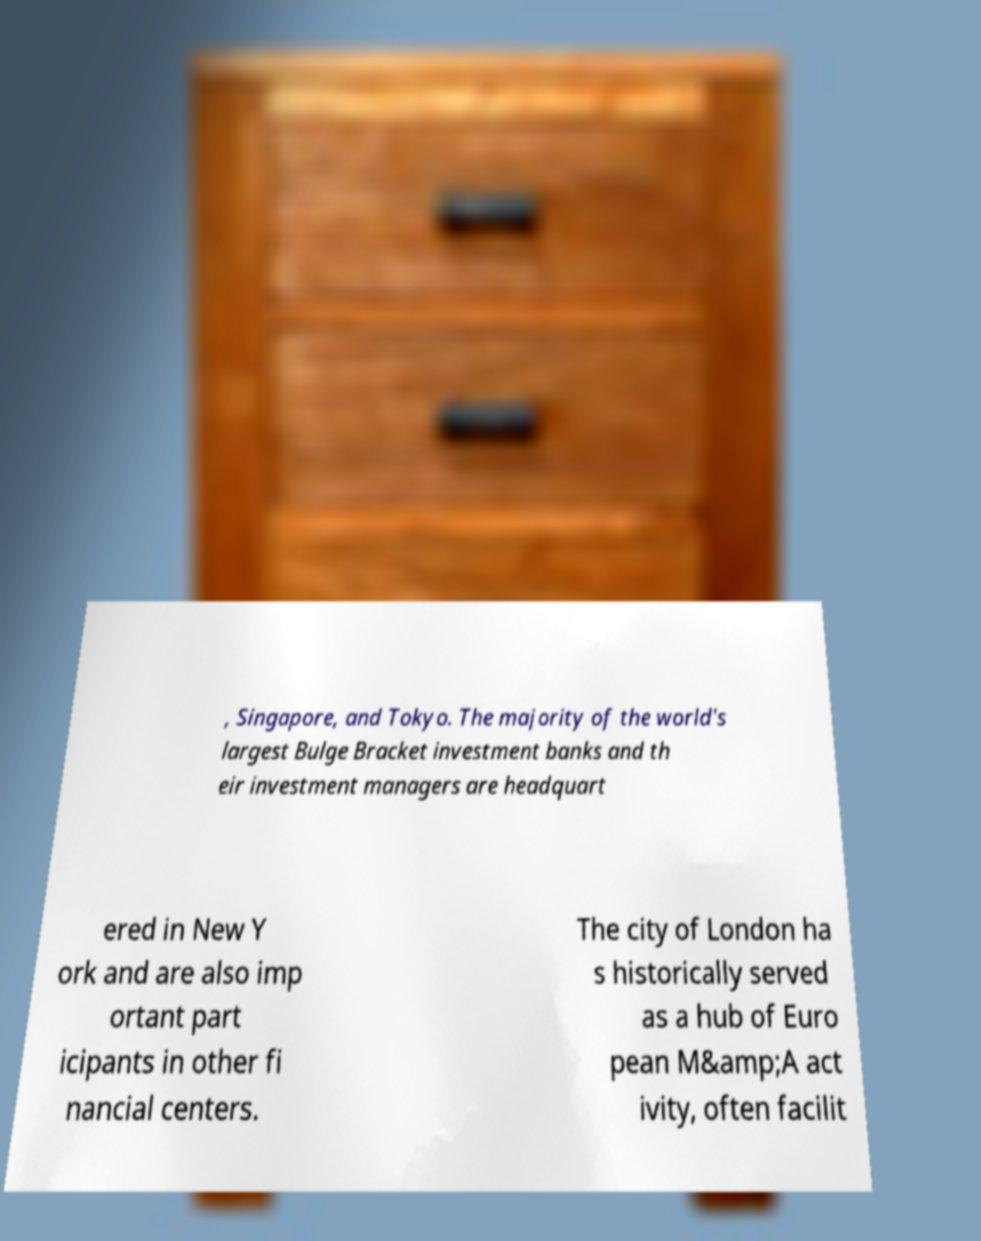Could you extract and type out the text from this image? , Singapore, and Tokyo. The majority of the world's largest Bulge Bracket investment banks and th eir investment managers are headquart ered in New Y ork and are also imp ortant part icipants in other fi nancial centers. The city of London ha s historically served as a hub of Euro pean M&amp;A act ivity, often facilit 